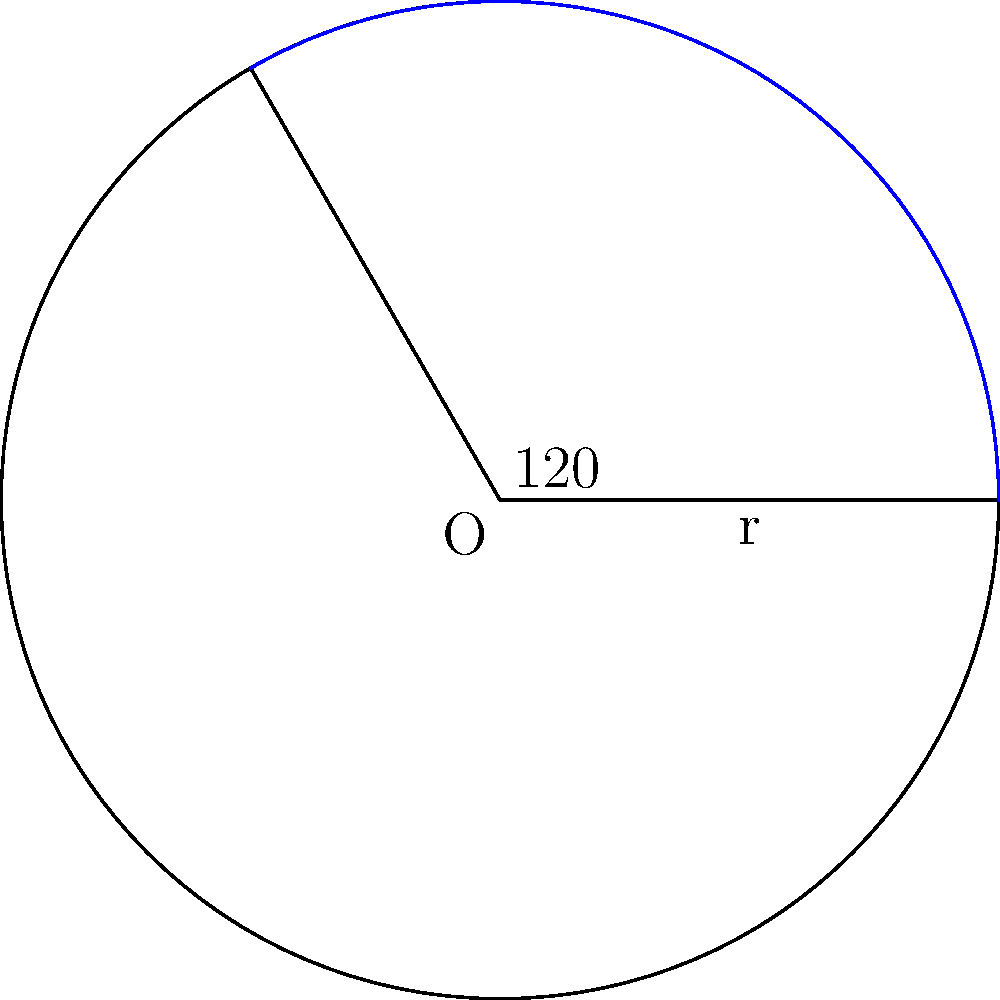In a classic tale of nautical exploration, a ship's captain needs to calculate the area of a circular sector representing the ship's radar range. If the radar covers a central angle of 120° and has a radius of 10 nautical miles, what is the area of this sector? Round your answer to the nearest square nautical mile. To calculate the area of a circular sector, we'll follow these steps:

1) The formula for the area of a circular sector is:
   $$A = \frac{1}{2} r^2 \theta$$
   where $r$ is the radius and $\theta$ is the central angle in radians.

2) We're given the radius $r = 10$ nautical miles.

3) We need to convert the central angle from degrees to radians:
   $$\theta = 120° \times \frac{\pi}{180°} = \frac{2\pi}{3} \approx 2.0944$$

4) Now we can substitute these values into our formula:
   $$A = \frac{1}{2} \times 10^2 \times \frac{2\pi}{3}$$

5) Simplify:
   $$A = \frac{100\pi}{3} \approx 104.72$$

6) Rounding to the nearest square nautical mile:
   $$A \approx 105 \text{ square nautical miles}$$
Answer: 105 square nautical miles 